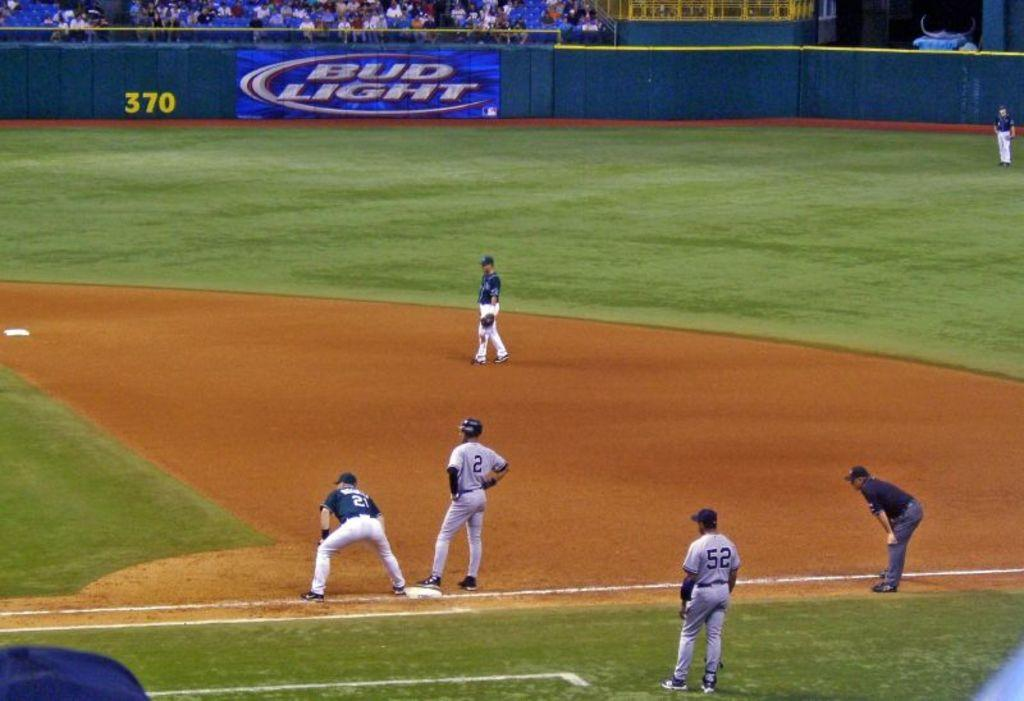<image>
Relay a brief, clear account of the picture shown. Ball players on the field in front of a Bud Light sign. 